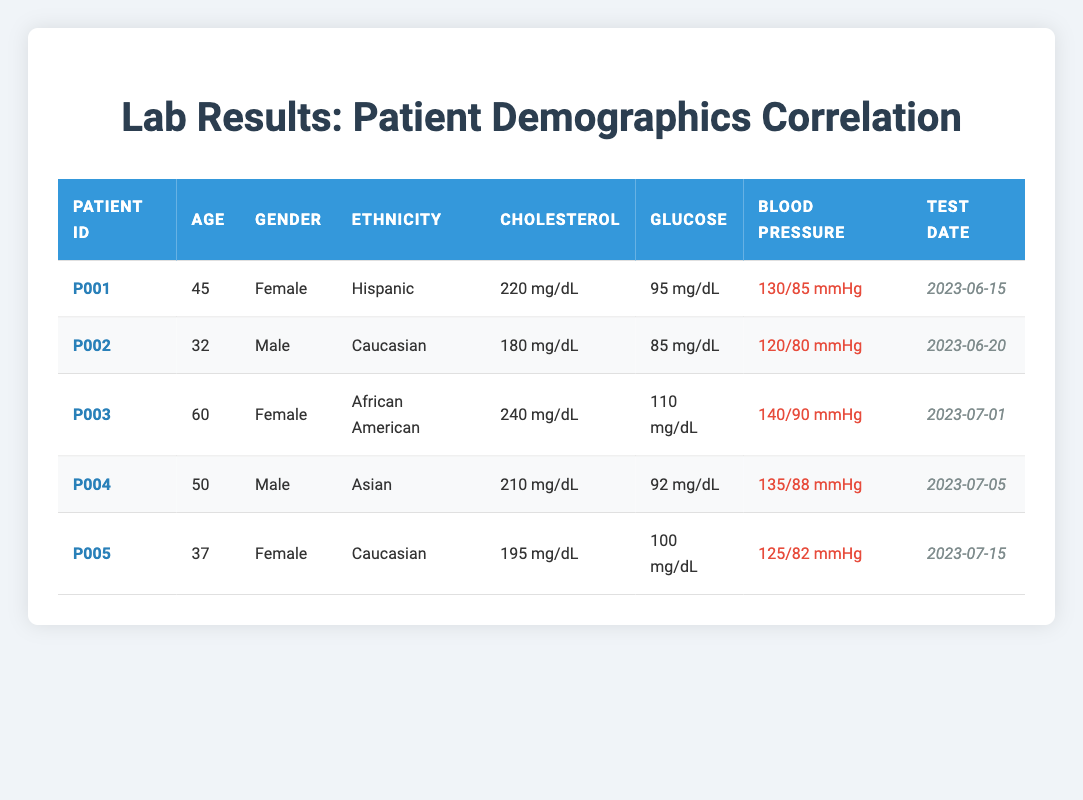What is the cholesterol level of patient P003? Patient P003 has a cholesterol level listed in the table as 240 mg/dL.
Answer: 240 mg/dL What is the average age of all patients in the table? To calculate the average age, we sum all ages: (45 + 32 + 60 + 50 + 37) = 224. Dividing by the number of patients (5) gives us an average age of 224/5 = 44.8.
Answer: 44.8 Is patient P002's blood pressure higher than 130/85? Patient P002's blood pressure is listed as 120/80, which is lower than 130/85.
Answer: No What is the cholesterol level of the oldest patient? The oldest patient is P003, who is 60 years old, with a cholesterol level of 240 mg/dL.
Answer: 240 mg/dL How many male patients have a cholesterol level greater than 200 mg/dL? There are two male patients listed: P002 (180 mg/dL) and P004 (210 mg/dL). Only P004 has a cholesterol level greater than 200 mg/dL.
Answer: 1 What is the difference in glucose levels between the youngest and oldest patient? The youngest patient is P002 with a glucose level of 85 mg/dL, and the oldest patient is P003 with a glucose level of 110 mg/dL. The difference is 110 - 85 = 25 mg/dL.
Answer: 25 mg/dL Is the cholesterol level of female patients consistently above 200 mg/dL? We check female patients P001 (220 mg/dL) and P003 (240 mg/dL). Since it is above 200 mg/dL for both, the statement is true.
Answer: Yes Which ethnicity corresponds to the patient with the lowest glucose level? Patient P002 has the lowest glucose level of 85 mg/dL, and is stated to be Caucasian.
Answer: Caucasian 